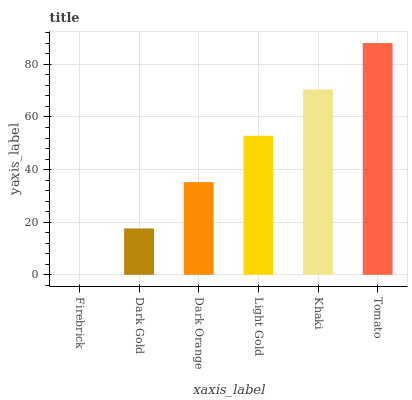Is Firebrick the minimum?
Answer yes or no. Yes. Is Tomato the maximum?
Answer yes or no. Yes. Is Dark Gold the minimum?
Answer yes or no. No. Is Dark Gold the maximum?
Answer yes or no. No. Is Dark Gold greater than Firebrick?
Answer yes or no. Yes. Is Firebrick less than Dark Gold?
Answer yes or no. Yes. Is Firebrick greater than Dark Gold?
Answer yes or no. No. Is Dark Gold less than Firebrick?
Answer yes or no. No. Is Light Gold the high median?
Answer yes or no. Yes. Is Dark Orange the low median?
Answer yes or no. Yes. Is Tomato the high median?
Answer yes or no. No. Is Tomato the low median?
Answer yes or no. No. 